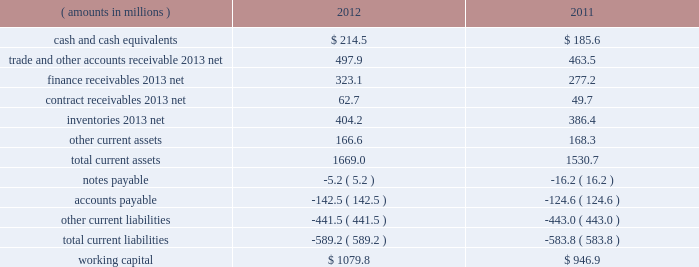Management 2019s discussion and analysis of financial condition and results of operations ( continued ) liquidity and capital resources snap-on 2019s growth has historically been funded by a combination of cash provided by operating activities and debt financing .
Snap-on believes that its cash from operations and collections of finance receivables , coupled with its sources of borrowings and available cash on hand , are sufficient to fund its currently anticipated requirements for payments of interest and dividends , new loans originated by our financial services businesses , capital expenditures , working capital , restructuring activities , the funding of pension plans , and funding for additional share repurchases and acquisitions , if any .
Due to snap-on 2019s credit rating over the years , external funds have been available at an acceptable cost .
As of the close of business on february 8 , 2013 , snap-on 2019s long-term debt and commercial paper were rated , respectively , baa1 and p-2 by moody 2019s investors service ; a- and a-2 by standard & poor 2019s ; and a- and f2 by fitch ratings .
Snap-on believes that its current credit arrangements are sound and that the strength of its balance sheet affords the company the financial flexibility to respond to both internal growth opportunities and those available through acquisitions .
However , snap-on cannot provide any assurances of the availability of future financing or the terms on which it might be available , or that its debt ratings may not decrease .
The following discussion focuses on information included in the accompanying consolidated balance sheets .
As of 2012 year end , working capital ( current assets less current liabilities ) of $ 1079.8 million increased $ 132.9 million from $ 946.9 million at 2011 year end .
The following represents the company 2019s working capital position as of 2012 and 2011 year end : ( amounts in millions ) 2012 2011 .
Cash and cash equivalents of $ 214.5 million as of 2012 year end compared to cash and cash equivalents of $ 185.6 million at 2011 year end .
The $ 28.9 million increase in cash and cash equivalents includes the impacts of ( i ) $ 329.3 million of cash generated from operations , net of $ 73.0 million of cash contributions ( including $ 54.7 million of discretionary contributions ) to the company 2019s domestic pension plans ; ( ii ) $ 445.5 million of cash from collections of finance receivables ; ( iii ) $ 46.8 million of proceeds from stock purchase and option plan exercises ; and ( iv ) $ 27.0 million of cash proceeds from the sale of a non-strategic equity investment at book value .
These increases in cash and cash equivalents were partially offset by ( i ) the funding of $ 569.6 million of new finance originations ; ( ii ) dividend payments of $ 81.5 million ; ( iii ) the funding of $ 79.4 million of capital expenditures ; and ( iv ) the repurchase of 1180000 shares of the company 2019s common stock for $ 78.1 million .
Of the $ 214.5 million of cash and cash equivalents as of 2012 year end , $ 81.4 million was held outside of the united states .
Snap-on considers these non-u.s .
Funds as permanently invested in its foreign operations to ( i ) provide adequate working capital ; ( ii ) satisfy various regulatory requirements ; and/or ( iii ) take advantage of business expansion opportunities as they arise ; as such , the company does not presently expect to repatriate these funds to fund its u.s .
Operations or obligations .
The repatriation of cash from certain foreign subsidiaries could have adverse net tax consequences on the company should snap-on be required to pay and record u.s .
Income taxes and foreign withholding taxes on funds that were previously considered permanently invested .
Alternatively , the repatriation of such cash from certain other foreign subsidiaries could result in favorable net tax consequences for the company .
Snap-on periodically evaluates opportunities to repatriate certain foreign cash amounts to the extent that it does not incur additional unfavorable net tax consequences .
44 snap-on incorporated .
What is the percentage change in working capital in 2012 relative to 2011? 
Computations: (132.9 / 946.9)
Answer: 0.14035. 